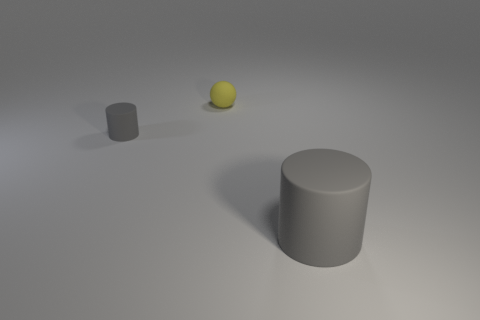There is a small object that is the same color as the big rubber thing; what shape is it?
Offer a terse response. Cylinder. There is a gray rubber cylinder right of the tiny yellow matte ball that is behind the big gray rubber cylinder; is there a cylinder that is to the right of it?
Provide a short and direct response. No. Are there an equal number of tiny gray matte things in front of the tiny yellow rubber thing and tiny gray matte cylinders that are to the left of the big gray matte cylinder?
Provide a short and direct response. Yes. There is a yellow matte thing that is behind the big gray cylinder; what is its shape?
Your answer should be very brief. Sphere. There is a rubber object that is the same size as the rubber ball; what is its shape?
Offer a terse response. Cylinder. There is a rubber thing that is behind the gray matte thing behind the gray matte cylinder that is right of the tiny yellow rubber thing; what is its color?
Make the answer very short. Yellow. Do the big rubber object and the tiny gray matte object have the same shape?
Give a very brief answer. Yes. Are there an equal number of spheres behind the tiny yellow matte object and big metallic balls?
Your answer should be compact. Yes. What number of other things are made of the same material as the tiny gray thing?
Offer a terse response. 2. There is a gray cylinder to the left of the large gray cylinder; does it have the same size as the rubber object that is behind the tiny cylinder?
Your answer should be compact. Yes. 